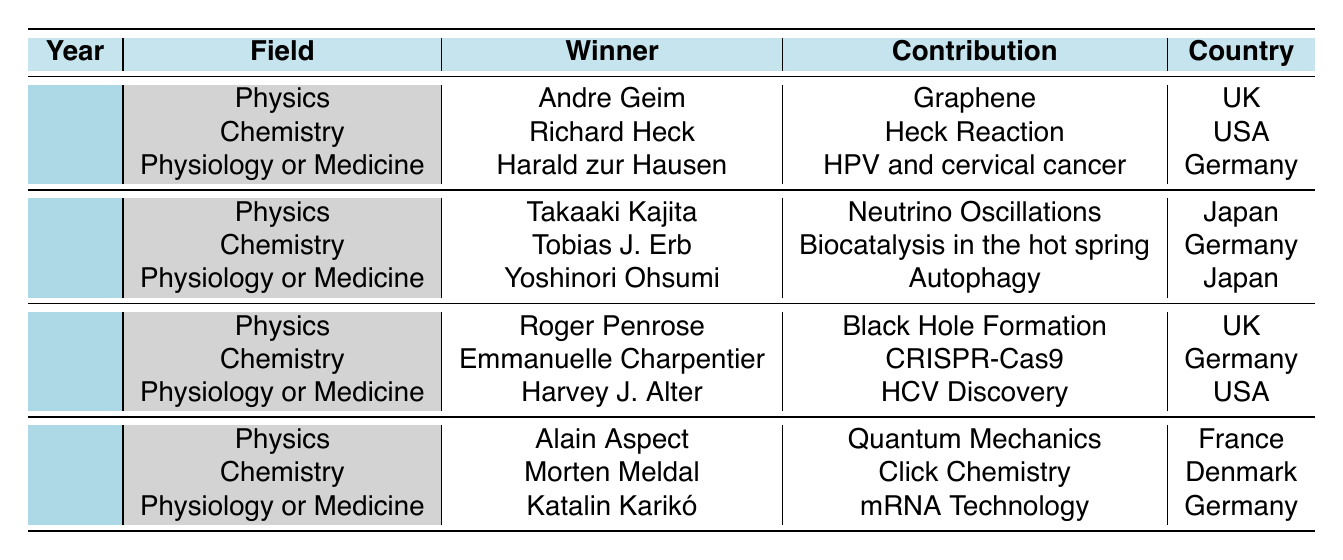What did Andre Geim win the Nobel Prize for in 2010? According to the table, Andre Geim won the Nobel Prize in Physics in 2010 for his contribution to graphene.
Answer: Graphene Which country did Richard Heck represent when he won the Nobel Prize in Chemistry? The table states that Richard Heck represented the USA while winning the Nobel Prize in Chemistry in 2010.
Answer: USA How many Nobel Prizes in Physics were awarded between 2010 and 2023? The table indicates that there were four Nobel Prizes in Physics awarded: 2010 (Andre Geim), 2015 (Takaaki Kajita), 2020 (Roger Penrose), and 2023 (Alain Aspect). Therefore, the total is 4.
Answer: 4 Which field had the same number of winners in 2015 as in 2020? The table shows that in both 2015 and 2020, there were three winners each in the fields of Physics, Chemistry, and Physiology or Medicine. Thus, each field had the same number of winners.
Answer: Yes Was Emmanuelle Charpentier's contribution awarded for work done in a hot spring? The table shows that Emmanuelle Charpentier won for CRISPR-Cas9, while Tobias J. Erb won for Biocatalysis in the hot spring in 2015. Thus, Emmanuelle Charpentier's contribution is not related to the hot spring.
Answer: No Who won the Nobel Prize in Physiology or Medicine in 2023? The table displays that Katalin Karikó won the Nobel Prize in Physiology or Medicine in 2023 for her contribution to mRNA technology.
Answer: Katalin Karikó What is the difference in the years when Physics Nobel Prizes were awarded between 2015 and 2020? The Nobel Prizes in Physics were awarded in 2015 and 2020. The difference in years is 2020 - 2015 = 5 years.
Answer: 5 years How many prizes were awarded for contributions from Germany in the field of Chemistry between 2010 and 2023? The table indicates that Richard Heck in 2010, Tobias J. Erb in 2015, and Emmanuelle Charpentier in 2020 represent contributions from Germany in Chemistry. Therefore, the total is 3 prizes.
Answer: 3 Which winner contributed to Black Hole Formation? According to the table, Roger Penrose contributed to Black Hole Formation and won the Nobel Prize in Physics in 2020.
Answer: Roger Penrose How many Nobel Prizes for Physiology or Medicine were awarded to Japanese winners? In the table, Yoshinori Ohsumi won the Nobel Prize in Physiology or Medicine in 2015 and Takaaki Kajita won in Physics. Thus, only one award in Physiology or Medicine was given to a Japanese winner.
Answer: 1 What was the contribution of Alain Aspect, and in which year did he win? The table states that Alain Aspect's contribution was to Quantum Mechanics, and he won the Nobel Prize in Physics in 2023.
Answer: Quantum Mechanics, 2023 